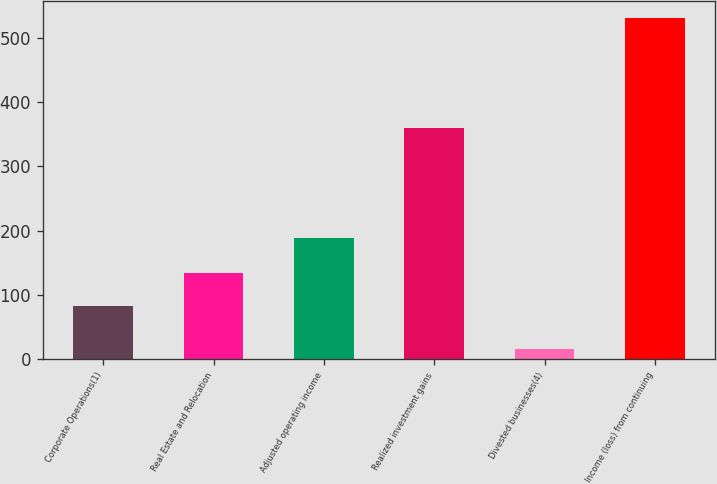Convert chart to OTSL. <chart><loc_0><loc_0><loc_500><loc_500><bar_chart><fcel>Corporate Operations(1)<fcel>Real Estate and Relocation<fcel>Adjusted operating income<fcel>Realized investment gains<fcel>Divested businesses(4)<fcel>Income (loss) from continuing<nl><fcel>83<fcel>134.5<fcel>188<fcel>359<fcel>16<fcel>531<nl></chart> 